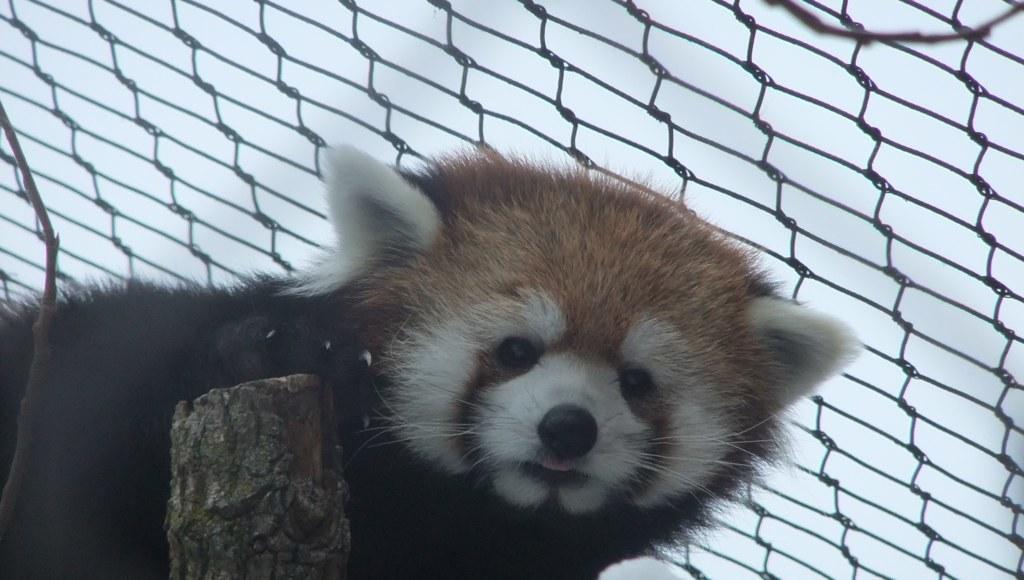Please provide a concise description of this image. In this image I can see a animal which is brown, white and black in color and I can see a wooden log. In the background I can see the net and the sky. 